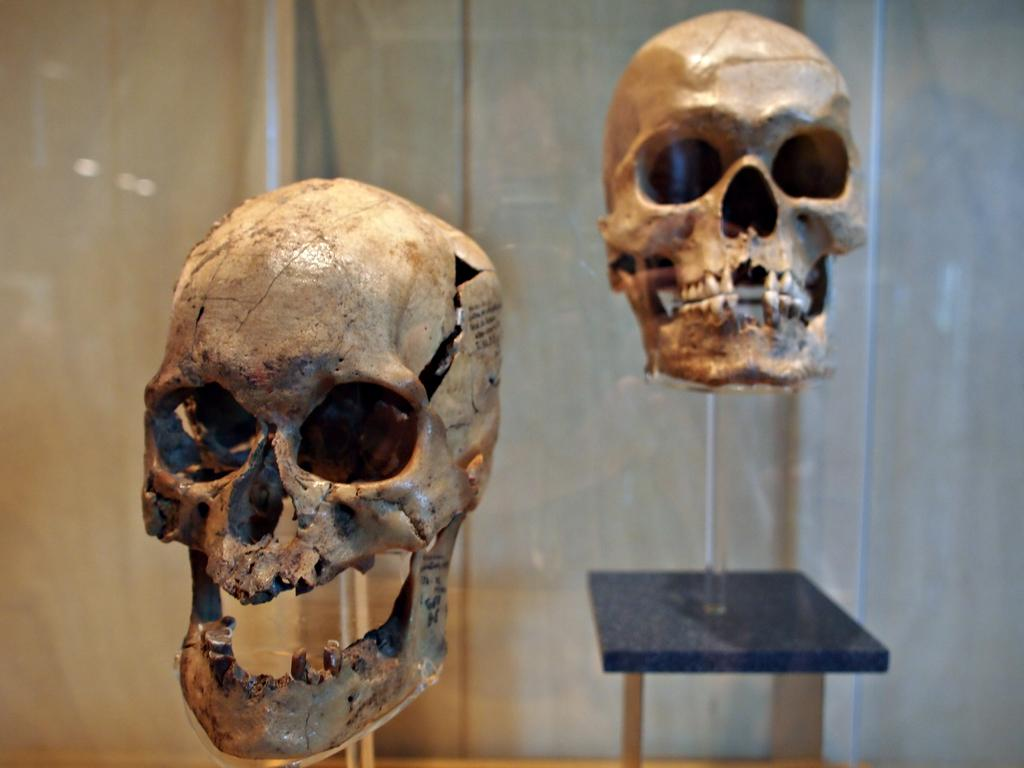What type of faces are depicted in the image? There are skeleton faces in the image. What can be seen supporting the skeleton faces? There is a stand in the image. What is visible in the background of the image? There is a wall in the background of the image. How many boats are visible in the image? There are no boats present in the image. Can you describe the ant's role in the image? There is no ant present in the image. 